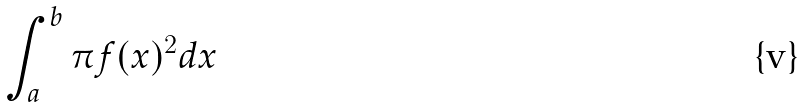<formula> <loc_0><loc_0><loc_500><loc_500>\int _ { a } ^ { b } \pi f ( x ) ^ { 2 } d x</formula> 